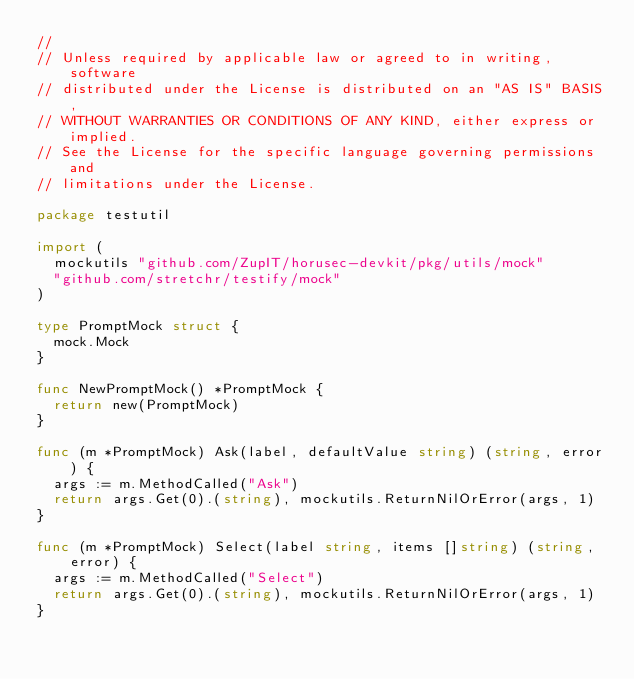<code> <loc_0><loc_0><loc_500><loc_500><_Go_>//
// Unless required by applicable law or agreed to in writing, software
// distributed under the License is distributed on an "AS IS" BASIS,
// WITHOUT WARRANTIES OR CONDITIONS OF ANY KIND, either express or implied.
// See the License for the specific language governing permissions and
// limitations under the License.

package testutil

import (
	mockutils "github.com/ZupIT/horusec-devkit/pkg/utils/mock"
	"github.com/stretchr/testify/mock"
)

type PromptMock struct {
	mock.Mock
}

func NewPromptMock() *PromptMock {
	return new(PromptMock)
}

func (m *PromptMock) Ask(label, defaultValue string) (string, error) {
	args := m.MethodCalled("Ask")
	return args.Get(0).(string), mockutils.ReturnNilOrError(args, 1)
}

func (m *PromptMock) Select(label string, items []string) (string, error) {
	args := m.MethodCalled("Select")
	return args.Get(0).(string), mockutils.ReturnNilOrError(args, 1)
}
</code> 